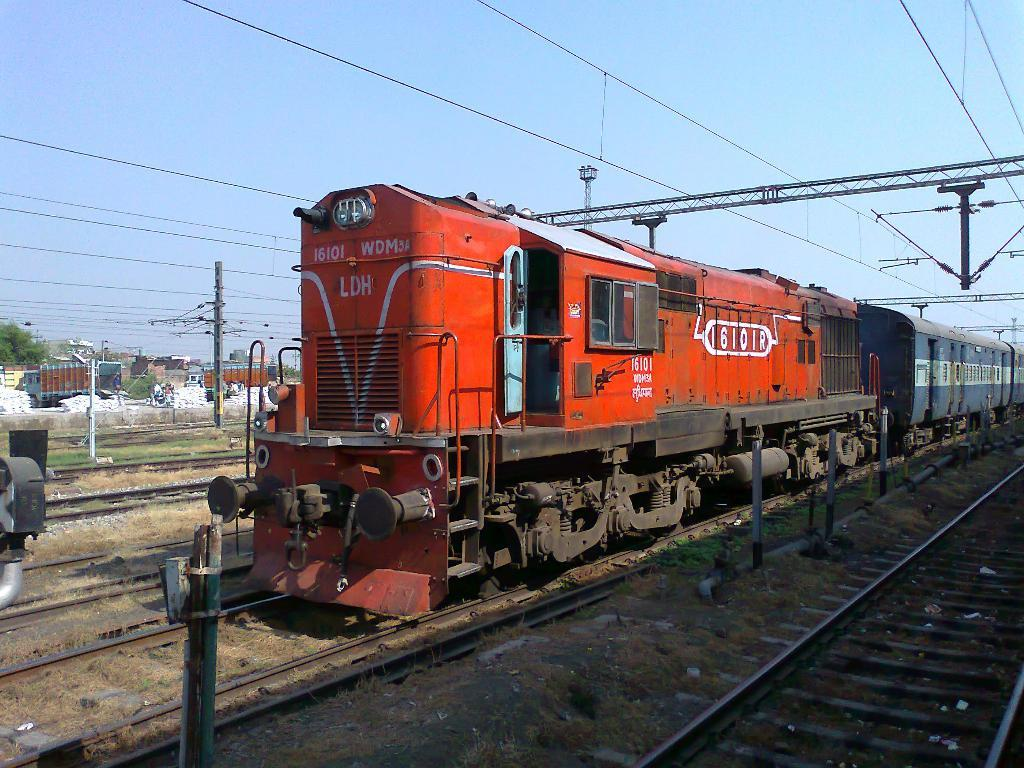<image>
Summarize the visual content of the image. Train number 16101R sits on the train tracks. 